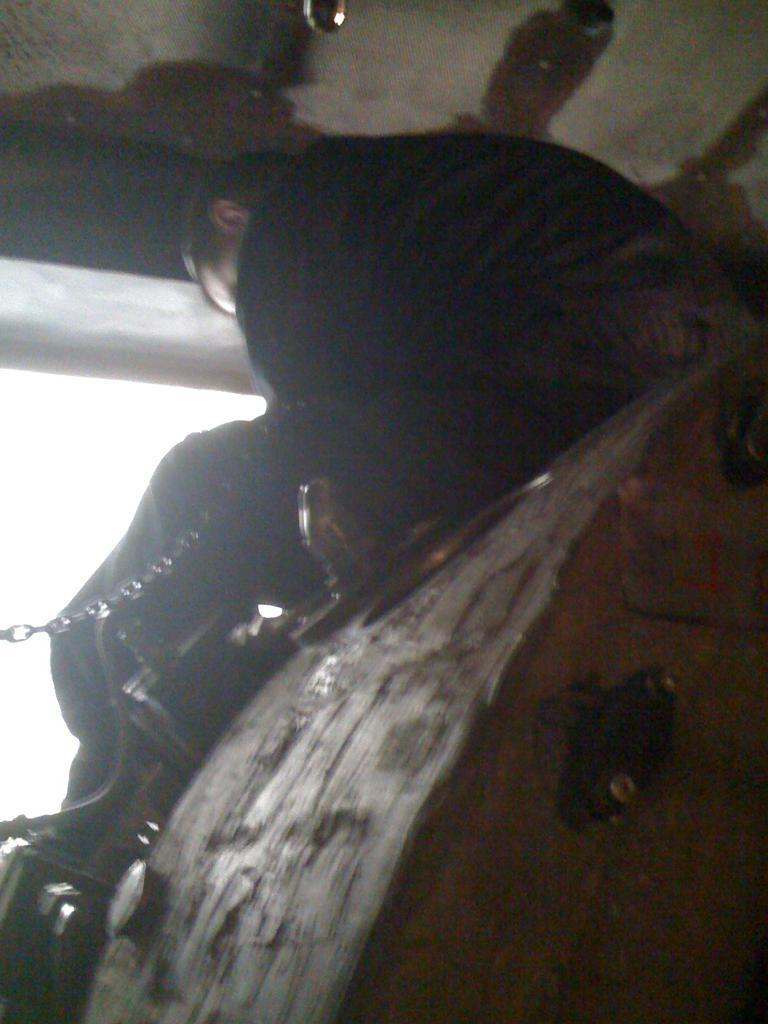What is the person in the image doing? There is a person sitting on an object in the image. What can be seen attached to the object the person is sitting on? There is a chain visible in the image. What is above the person in the image? There is a ceiling in the image. What is visible beyond the ceiling in the image? The sky is visible in the image. What type of rhythm is the person playing on the spade in the image? There is no spade or rhythm present in the image; the person is simply sitting on an object with a chain attached. 